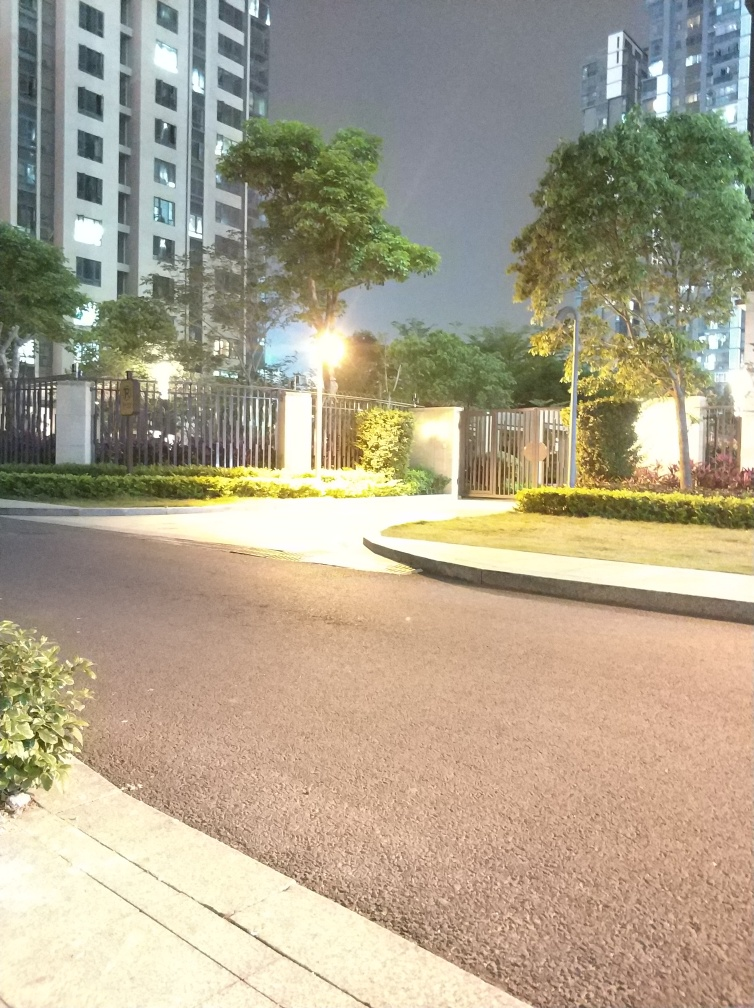What kind of atmosphere or mood does the lighting in this picture convey? The lighting in the picture conveys a somewhat stark and deserted atmosphere. The brightness of the artificial lights against the dark background emphasizes the emptiness of the space, suggesting a quiet and possibly late-hour scenario. Could you surmise what the function of this space might be, based on its features? Based on features such as the paved road, the curb, and the well-maintained vegetation, this space seems to be a part of a residential area, possibly near an apartment complex, meant for pedestrian and vehicular movement. 